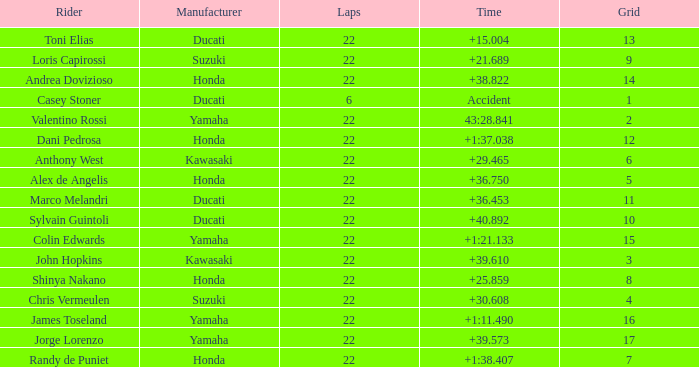Who had the lowest laps on a grid smaller than 16 with a time of +21.689? 22.0. Parse the table in full. {'header': ['Rider', 'Manufacturer', 'Laps', 'Time', 'Grid'], 'rows': [['Toni Elias', 'Ducati', '22', '+15.004', '13'], ['Loris Capirossi', 'Suzuki', '22', '+21.689', '9'], ['Andrea Dovizioso', 'Honda', '22', '+38.822', '14'], ['Casey Stoner', 'Ducati', '6', 'Accident', '1'], ['Valentino Rossi', 'Yamaha', '22', '43:28.841', '2'], ['Dani Pedrosa', 'Honda', '22', '+1:37.038', '12'], ['Anthony West', 'Kawasaki', '22', '+29.465', '6'], ['Alex de Angelis', 'Honda', '22', '+36.750', '5'], ['Marco Melandri', 'Ducati', '22', '+36.453', '11'], ['Sylvain Guintoli', 'Ducati', '22', '+40.892', '10'], ['Colin Edwards', 'Yamaha', '22', '+1:21.133', '15'], ['John Hopkins', 'Kawasaki', '22', '+39.610', '3'], ['Shinya Nakano', 'Honda', '22', '+25.859', '8'], ['Chris Vermeulen', 'Suzuki', '22', '+30.608', '4'], ['James Toseland', 'Yamaha', '22', '+1:11.490', '16'], ['Jorge Lorenzo', 'Yamaha', '22', '+39.573', '17'], ['Randy de Puniet', 'Honda', '22', '+1:38.407', '7']]} 